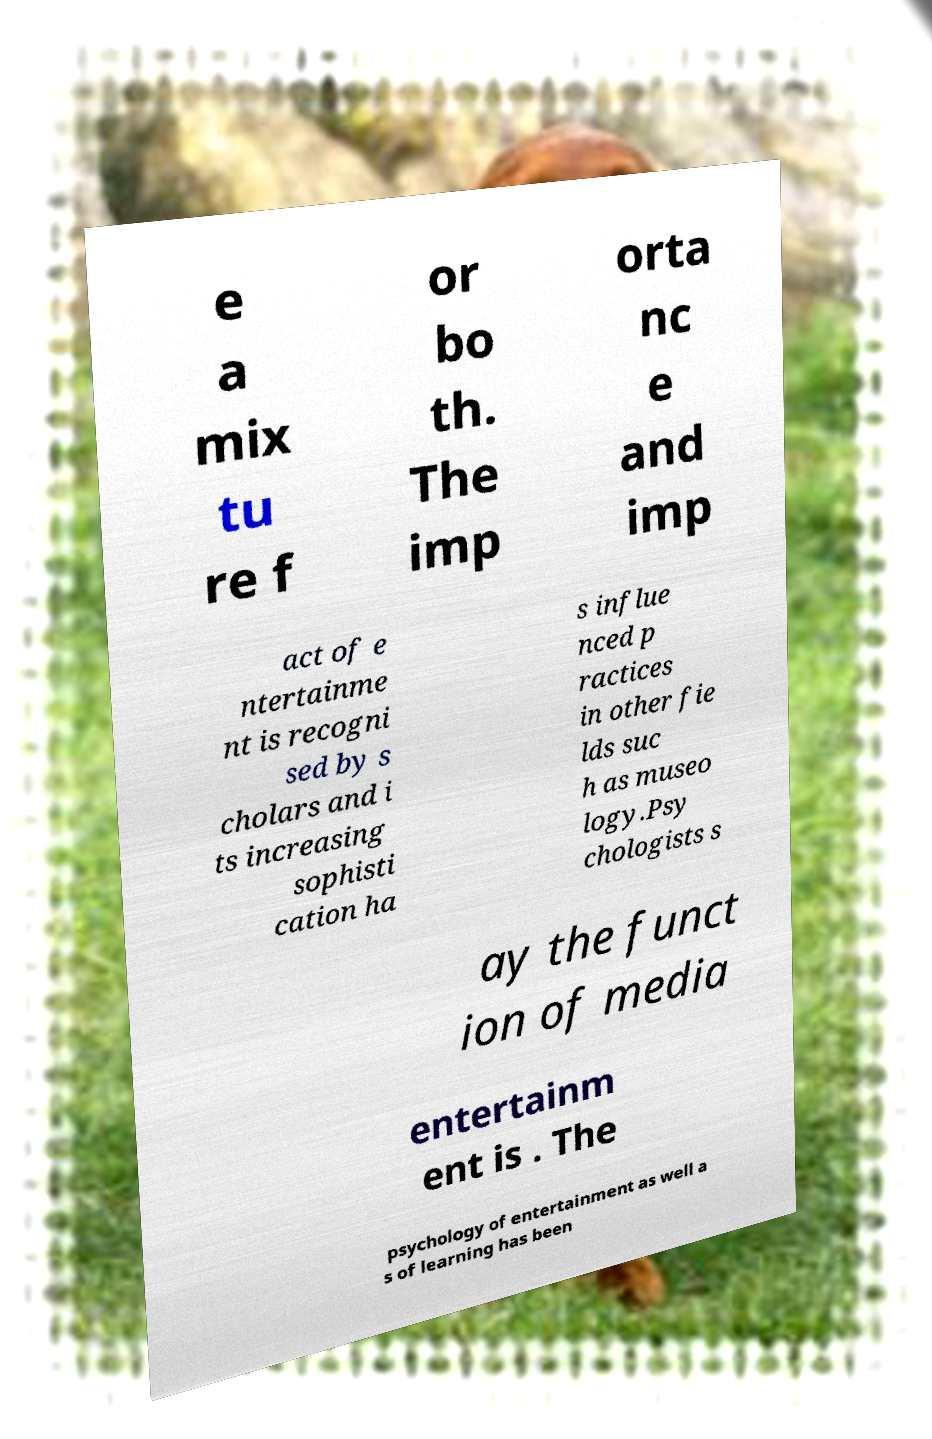There's text embedded in this image that I need extracted. Can you transcribe it verbatim? e a mix tu re f or bo th. The imp orta nc e and imp act of e ntertainme nt is recogni sed by s cholars and i ts increasing sophisti cation ha s influe nced p ractices in other fie lds suc h as museo logy.Psy chologists s ay the funct ion of media entertainm ent is . The psychology of entertainment as well a s of learning has been 